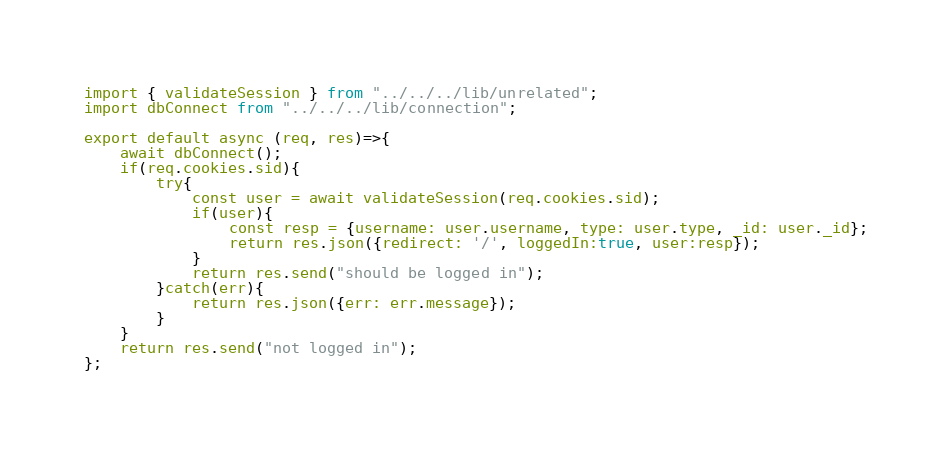<code> <loc_0><loc_0><loc_500><loc_500><_JavaScript_>import { validateSession } from "../../../lib/unrelated";
import dbConnect from "../../../lib/connection";

export default async (req, res)=>{
    await dbConnect();
    if(req.cookies.sid){
        try{
            const user = await validateSession(req.cookies.sid);
            if(user){
                const resp = {username: user.username, type: user.type, _id: user._id};
                return res.json({redirect: '/', loggedIn:true, user:resp});
            }
            return res.send("should be logged in");
        }catch(err){
            return res.json({err: err.message});
        }
    }
    return res.send("not logged in");
};</code> 